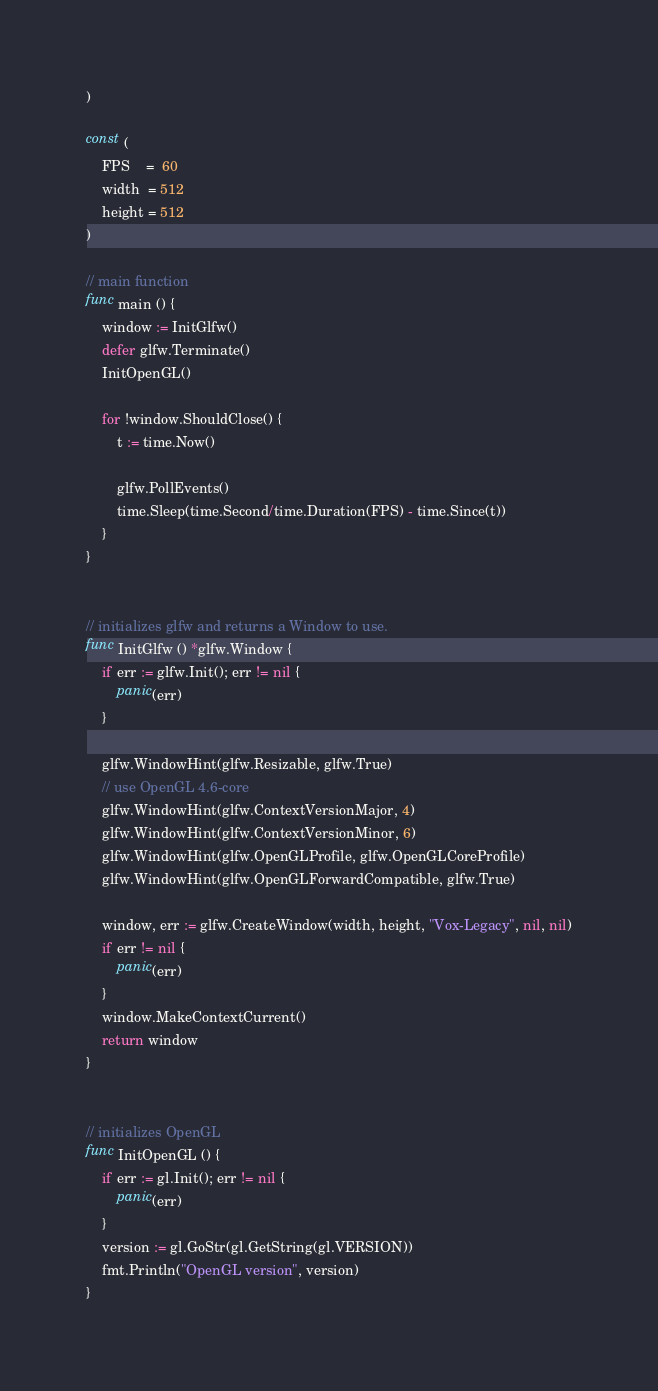<code> <loc_0><loc_0><loc_500><loc_500><_Go_>)

const (
    FPS    =  60
    width  = 512
    height = 512
)

// main function
func main () {
    window := InitGlfw()
    defer glfw.Terminate()
    InitOpenGL()

    for !window.ShouldClose() {
		t := time.Now()

        glfw.PollEvents()
		time.Sleep(time.Second/time.Duration(FPS) - time.Since(t))
    }
}


// initializes glfw and returns a Window to use.
func InitGlfw () *glfw.Window {
    if err := glfw.Init(); err != nil {
		panic(err)
    }

    glfw.WindowHint(glfw.Resizable, glfw.True)
	// use OpenGL 4.6-core
    glfw.WindowHint(glfw.ContextVersionMajor, 4)
    glfw.WindowHint(glfw.ContextVersionMinor, 6)
    glfw.WindowHint(glfw.OpenGLProfile, glfw.OpenGLCoreProfile)
    glfw.WindowHint(glfw.OpenGLForwardCompatible, glfw.True)

    window, err := glfw.CreateWindow(width, height, "Vox-Legacy", nil, nil)
    if err != nil {
		panic(err)
    }
    window.MakeContextCurrent()
    return window
}


// initializes OpenGL
func InitOpenGL () {
    if err := gl.Init(); err != nil {
		panic(err)
    }
    version := gl.GoStr(gl.GetString(gl.VERSION))
    fmt.Println("OpenGL version", version)
}
</code> 